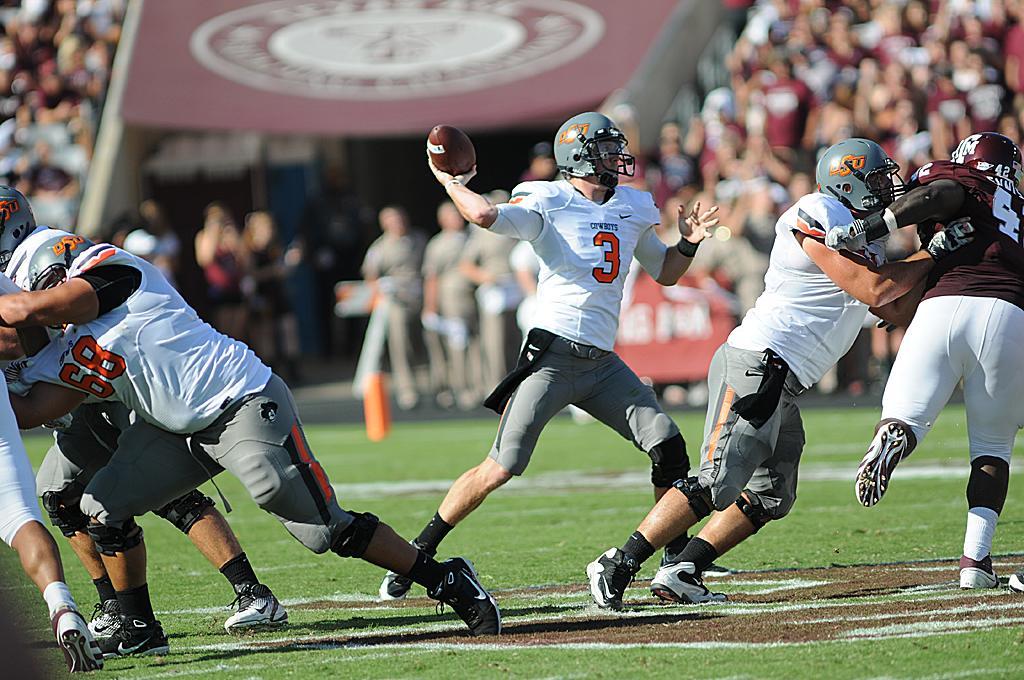Can you describe this image briefly? In this image, we can see few people are playing a game on the grass. Here a person holding a ball. Background there is a blur view and we can see people. 